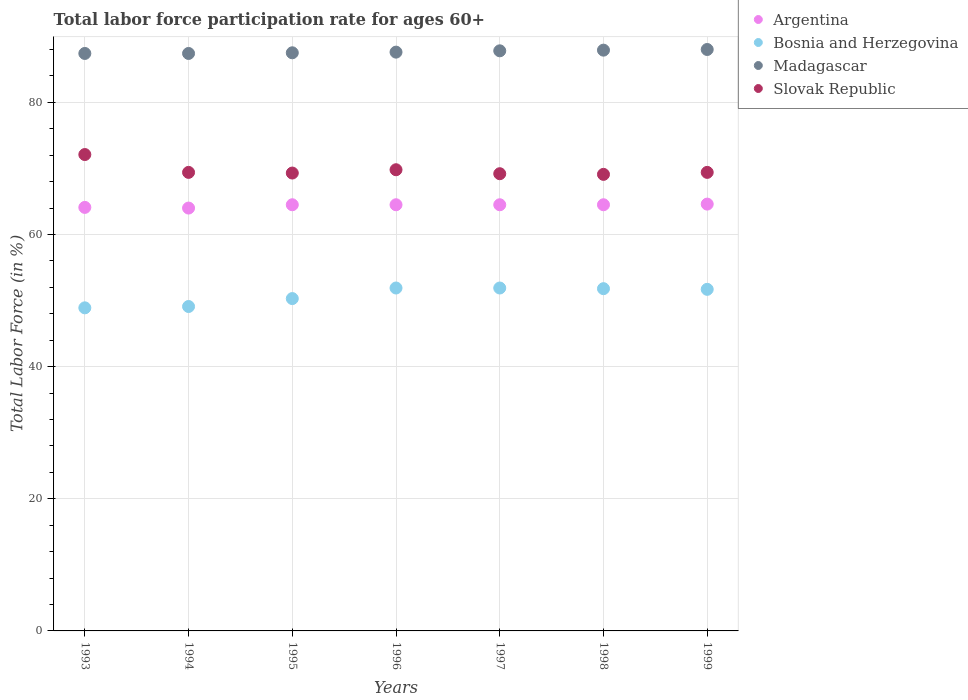How many different coloured dotlines are there?
Provide a short and direct response. 4. What is the labor force participation rate in Bosnia and Herzegovina in 1996?
Your answer should be very brief. 51.9. Across all years, what is the minimum labor force participation rate in Bosnia and Herzegovina?
Your response must be concise. 48.9. In which year was the labor force participation rate in Madagascar maximum?
Give a very brief answer. 1999. What is the total labor force participation rate in Argentina in the graph?
Your answer should be compact. 450.7. What is the difference between the labor force participation rate in Bosnia and Herzegovina in 1995 and that in 1997?
Your answer should be compact. -1.6. What is the difference between the labor force participation rate in Madagascar in 1995 and the labor force participation rate in Slovak Republic in 1999?
Offer a terse response. 18.1. What is the average labor force participation rate in Bosnia and Herzegovina per year?
Offer a very short reply. 50.8. In the year 1998, what is the difference between the labor force participation rate in Madagascar and labor force participation rate in Argentina?
Give a very brief answer. 23.4. What is the ratio of the labor force participation rate in Argentina in 1994 to that in 1997?
Your answer should be compact. 0.99. What is the difference between the highest and the second highest labor force participation rate in Madagascar?
Give a very brief answer. 0.1. What is the difference between the highest and the lowest labor force participation rate in Madagascar?
Give a very brief answer. 0.6. Is it the case that in every year, the sum of the labor force participation rate in Slovak Republic and labor force participation rate in Argentina  is greater than the sum of labor force participation rate in Bosnia and Herzegovina and labor force participation rate in Madagascar?
Keep it short and to the point. Yes. Is it the case that in every year, the sum of the labor force participation rate in Slovak Republic and labor force participation rate in Argentina  is greater than the labor force participation rate in Bosnia and Herzegovina?
Your answer should be compact. Yes. Is the labor force participation rate in Argentina strictly greater than the labor force participation rate in Bosnia and Herzegovina over the years?
Offer a very short reply. Yes. Is the labor force participation rate in Slovak Republic strictly less than the labor force participation rate in Bosnia and Herzegovina over the years?
Give a very brief answer. No. How many years are there in the graph?
Make the answer very short. 7. Are the values on the major ticks of Y-axis written in scientific E-notation?
Ensure brevity in your answer.  No. Does the graph contain grids?
Offer a terse response. Yes. What is the title of the graph?
Keep it short and to the point. Total labor force participation rate for ages 60+. Does "Algeria" appear as one of the legend labels in the graph?
Ensure brevity in your answer.  No. What is the Total Labor Force (in %) of Argentina in 1993?
Make the answer very short. 64.1. What is the Total Labor Force (in %) in Bosnia and Herzegovina in 1993?
Provide a succinct answer. 48.9. What is the Total Labor Force (in %) in Madagascar in 1993?
Your answer should be very brief. 87.4. What is the Total Labor Force (in %) of Slovak Republic in 1993?
Keep it short and to the point. 72.1. What is the Total Labor Force (in %) in Bosnia and Herzegovina in 1994?
Your response must be concise. 49.1. What is the Total Labor Force (in %) of Madagascar in 1994?
Your answer should be compact. 87.4. What is the Total Labor Force (in %) of Slovak Republic in 1994?
Offer a terse response. 69.4. What is the Total Labor Force (in %) of Argentina in 1995?
Provide a short and direct response. 64.5. What is the Total Labor Force (in %) of Bosnia and Herzegovina in 1995?
Provide a short and direct response. 50.3. What is the Total Labor Force (in %) of Madagascar in 1995?
Provide a succinct answer. 87.5. What is the Total Labor Force (in %) in Slovak Republic in 1995?
Keep it short and to the point. 69.3. What is the Total Labor Force (in %) in Argentina in 1996?
Provide a short and direct response. 64.5. What is the Total Labor Force (in %) of Bosnia and Herzegovina in 1996?
Ensure brevity in your answer.  51.9. What is the Total Labor Force (in %) in Madagascar in 1996?
Ensure brevity in your answer.  87.6. What is the Total Labor Force (in %) in Slovak Republic in 1996?
Keep it short and to the point. 69.8. What is the Total Labor Force (in %) in Argentina in 1997?
Make the answer very short. 64.5. What is the Total Labor Force (in %) of Bosnia and Herzegovina in 1997?
Keep it short and to the point. 51.9. What is the Total Labor Force (in %) in Madagascar in 1997?
Make the answer very short. 87.8. What is the Total Labor Force (in %) in Slovak Republic in 1997?
Offer a terse response. 69.2. What is the Total Labor Force (in %) in Argentina in 1998?
Your answer should be very brief. 64.5. What is the Total Labor Force (in %) of Bosnia and Herzegovina in 1998?
Offer a very short reply. 51.8. What is the Total Labor Force (in %) in Madagascar in 1998?
Offer a terse response. 87.9. What is the Total Labor Force (in %) in Slovak Republic in 1998?
Provide a succinct answer. 69.1. What is the Total Labor Force (in %) of Argentina in 1999?
Give a very brief answer. 64.6. What is the Total Labor Force (in %) in Bosnia and Herzegovina in 1999?
Your answer should be very brief. 51.7. What is the Total Labor Force (in %) in Slovak Republic in 1999?
Make the answer very short. 69.4. Across all years, what is the maximum Total Labor Force (in %) in Argentina?
Offer a very short reply. 64.6. Across all years, what is the maximum Total Labor Force (in %) in Bosnia and Herzegovina?
Offer a very short reply. 51.9. Across all years, what is the maximum Total Labor Force (in %) in Slovak Republic?
Offer a terse response. 72.1. Across all years, what is the minimum Total Labor Force (in %) of Bosnia and Herzegovina?
Offer a very short reply. 48.9. Across all years, what is the minimum Total Labor Force (in %) of Madagascar?
Provide a short and direct response. 87.4. Across all years, what is the minimum Total Labor Force (in %) of Slovak Republic?
Your answer should be very brief. 69.1. What is the total Total Labor Force (in %) in Argentina in the graph?
Offer a very short reply. 450.7. What is the total Total Labor Force (in %) of Bosnia and Herzegovina in the graph?
Provide a short and direct response. 355.6. What is the total Total Labor Force (in %) of Madagascar in the graph?
Your response must be concise. 613.6. What is the total Total Labor Force (in %) of Slovak Republic in the graph?
Give a very brief answer. 488.3. What is the difference between the Total Labor Force (in %) of Argentina in 1993 and that in 1994?
Your answer should be very brief. 0.1. What is the difference between the Total Labor Force (in %) of Bosnia and Herzegovina in 1993 and that in 1994?
Provide a succinct answer. -0.2. What is the difference between the Total Labor Force (in %) in Madagascar in 1993 and that in 1994?
Your answer should be very brief. 0. What is the difference between the Total Labor Force (in %) of Slovak Republic in 1993 and that in 1994?
Offer a very short reply. 2.7. What is the difference between the Total Labor Force (in %) in Argentina in 1993 and that in 1995?
Your answer should be compact. -0.4. What is the difference between the Total Labor Force (in %) in Bosnia and Herzegovina in 1993 and that in 1995?
Ensure brevity in your answer.  -1.4. What is the difference between the Total Labor Force (in %) in Madagascar in 1993 and that in 1995?
Provide a short and direct response. -0.1. What is the difference between the Total Labor Force (in %) of Argentina in 1993 and that in 1996?
Provide a succinct answer. -0.4. What is the difference between the Total Labor Force (in %) in Argentina in 1993 and that in 1997?
Offer a terse response. -0.4. What is the difference between the Total Labor Force (in %) in Madagascar in 1993 and that in 1997?
Your response must be concise. -0.4. What is the difference between the Total Labor Force (in %) in Bosnia and Herzegovina in 1993 and that in 1998?
Your answer should be compact. -2.9. What is the difference between the Total Labor Force (in %) in Argentina in 1993 and that in 1999?
Offer a very short reply. -0.5. What is the difference between the Total Labor Force (in %) of Bosnia and Herzegovina in 1993 and that in 1999?
Provide a short and direct response. -2.8. What is the difference between the Total Labor Force (in %) in Madagascar in 1993 and that in 1999?
Your response must be concise. -0.6. What is the difference between the Total Labor Force (in %) in Argentina in 1994 and that in 1995?
Offer a very short reply. -0.5. What is the difference between the Total Labor Force (in %) in Madagascar in 1994 and that in 1995?
Provide a succinct answer. -0.1. What is the difference between the Total Labor Force (in %) of Argentina in 1994 and that in 1996?
Make the answer very short. -0.5. What is the difference between the Total Labor Force (in %) in Madagascar in 1994 and that in 1996?
Provide a succinct answer. -0.2. What is the difference between the Total Labor Force (in %) in Argentina in 1994 and that in 1997?
Your response must be concise. -0.5. What is the difference between the Total Labor Force (in %) in Slovak Republic in 1994 and that in 1997?
Keep it short and to the point. 0.2. What is the difference between the Total Labor Force (in %) in Argentina in 1994 and that in 1998?
Your answer should be very brief. -0.5. What is the difference between the Total Labor Force (in %) of Bosnia and Herzegovina in 1994 and that in 1998?
Keep it short and to the point. -2.7. What is the difference between the Total Labor Force (in %) in Slovak Republic in 1994 and that in 1999?
Your answer should be very brief. 0. What is the difference between the Total Labor Force (in %) in Argentina in 1995 and that in 1996?
Provide a succinct answer. 0. What is the difference between the Total Labor Force (in %) in Bosnia and Herzegovina in 1995 and that in 1996?
Offer a very short reply. -1.6. What is the difference between the Total Labor Force (in %) in Bosnia and Herzegovina in 1995 and that in 1997?
Your response must be concise. -1.6. What is the difference between the Total Labor Force (in %) in Slovak Republic in 1995 and that in 1997?
Give a very brief answer. 0.1. What is the difference between the Total Labor Force (in %) of Madagascar in 1995 and that in 1998?
Offer a very short reply. -0.4. What is the difference between the Total Labor Force (in %) of Slovak Republic in 1995 and that in 1998?
Your answer should be very brief. 0.2. What is the difference between the Total Labor Force (in %) of Argentina in 1995 and that in 1999?
Provide a succinct answer. -0.1. What is the difference between the Total Labor Force (in %) of Slovak Republic in 1995 and that in 1999?
Give a very brief answer. -0.1. What is the difference between the Total Labor Force (in %) in Argentina in 1996 and that in 1997?
Provide a short and direct response. 0. What is the difference between the Total Labor Force (in %) of Bosnia and Herzegovina in 1996 and that in 1997?
Offer a terse response. 0. What is the difference between the Total Labor Force (in %) of Madagascar in 1996 and that in 1997?
Ensure brevity in your answer.  -0.2. What is the difference between the Total Labor Force (in %) in Argentina in 1996 and that in 1998?
Give a very brief answer. 0. What is the difference between the Total Labor Force (in %) in Madagascar in 1996 and that in 1998?
Provide a short and direct response. -0.3. What is the difference between the Total Labor Force (in %) of Madagascar in 1996 and that in 1999?
Make the answer very short. -0.4. What is the difference between the Total Labor Force (in %) of Slovak Republic in 1996 and that in 1999?
Keep it short and to the point. 0.4. What is the difference between the Total Labor Force (in %) of Bosnia and Herzegovina in 1997 and that in 1998?
Your answer should be very brief. 0.1. What is the difference between the Total Labor Force (in %) of Argentina in 1997 and that in 1999?
Provide a short and direct response. -0.1. What is the difference between the Total Labor Force (in %) in Madagascar in 1997 and that in 1999?
Ensure brevity in your answer.  -0.2. What is the difference between the Total Labor Force (in %) in Argentina in 1998 and that in 1999?
Your answer should be compact. -0.1. What is the difference between the Total Labor Force (in %) in Bosnia and Herzegovina in 1998 and that in 1999?
Ensure brevity in your answer.  0.1. What is the difference between the Total Labor Force (in %) in Madagascar in 1998 and that in 1999?
Provide a short and direct response. -0.1. What is the difference between the Total Labor Force (in %) of Slovak Republic in 1998 and that in 1999?
Provide a succinct answer. -0.3. What is the difference between the Total Labor Force (in %) in Argentina in 1993 and the Total Labor Force (in %) in Madagascar in 1994?
Keep it short and to the point. -23.3. What is the difference between the Total Labor Force (in %) of Bosnia and Herzegovina in 1993 and the Total Labor Force (in %) of Madagascar in 1994?
Provide a succinct answer. -38.5. What is the difference between the Total Labor Force (in %) of Bosnia and Herzegovina in 1993 and the Total Labor Force (in %) of Slovak Republic in 1994?
Give a very brief answer. -20.5. What is the difference between the Total Labor Force (in %) of Argentina in 1993 and the Total Labor Force (in %) of Bosnia and Herzegovina in 1995?
Your answer should be very brief. 13.8. What is the difference between the Total Labor Force (in %) in Argentina in 1993 and the Total Labor Force (in %) in Madagascar in 1995?
Provide a succinct answer. -23.4. What is the difference between the Total Labor Force (in %) of Bosnia and Herzegovina in 1993 and the Total Labor Force (in %) of Madagascar in 1995?
Provide a short and direct response. -38.6. What is the difference between the Total Labor Force (in %) of Bosnia and Herzegovina in 1993 and the Total Labor Force (in %) of Slovak Republic in 1995?
Ensure brevity in your answer.  -20.4. What is the difference between the Total Labor Force (in %) of Argentina in 1993 and the Total Labor Force (in %) of Madagascar in 1996?
Offer a very short reply. -23.5. What is the difference between the Total Labor Force (in %) in Argentina in 1993 and the Total Labor Force (in %) in Slovak Republic in 1996?
Give a very brief answer. -5.7. What is the difference between the Total Labor Force (in %) in Bosnia and Herzegovina in 1993 and the Total Labor Force (in %) in Madagascar in 1996?
Provide a short and direct response. -38.7. What is the difference between the Total Labor Force (in %) in Bosnia and Herzegovina in 1993 and the Total Labor Force (in %) in Slovak Republic in 1996?
Keep it short and to the point. -20.9. What is the difference between the Total Labor Force (in %) in Madagascar in 1993 and the Total Labor Force (in %) in Slovak Republic in 1996?
Make the answer very short. 17.6. What is the difference between the Total Labor Force (in %) in Argentina in 1993 and the Total Labor Force (in %) in Bosnia and Herzegovina in 1997?
Your answer should be very brief. 12.2. What is the difference between the Total Labor Force (in %) of Argentina in 1993 and the Total Labor Force (in %) of Madagascar in 1997?
Your answer should be very brief. -23.7. What is the difference between the Total Labor Force (in %) of Argentina in 1993 and the Total Labor Force (in %) of Slovak Republic in 1997?
Your answer should be compact. -5.1. What is the difference between the Total Labor Force (in %) in Bosnia and Herzegovina in 1993 and the Total Labor Force (in %) in Madagascar in 1997?
Your answer should be very brief. -38.9. What is the difference between the Total Labor Force (in %) of Bosnia and Herzegovina in 1993 and the Total Labor Force (in %) of Slovak Republic in 1997?
Offer a very short reply. -20.3. What is the difference between the Total Labor Force (in %) in Madagascar in 1993 and the Total Labor Force (in %) in Slovak Republic in 1997?
Ensure brevity in your answer.  18.2. What is the difference between the Total Labor Force (in %) in Argentina in 1993 and the Total Labor Force (in %) in Madagascar in 1998?
Your answer should be compact. -23.8. What is the difference between the Total Labor Force (in %) of Argentina in 1993 and the Total Labor Force (in %) of Slovak Republic in 1998?
Your response must be concise. -5. What is the difference between the Total Labor Force (in %) of Bosnia and Herzegovina in 1993 and the Total Labor Force (in %) of Madagascar in 1998?
Give a very brief answer. -39. What is the difference between the Total Labor Force (in %) in Bosnia and Herzegovina in 1993 and the Total Labor Force (in %) in Slovak Republic in 1998?
Keep it short and to the point. -20.2. What is the difference between the Total Labor Force (in %) of Madagascar in 1993 and the Total Labor Force (in %) of Slovak Republic in 1998?
Make the answer very short. 18.3. What is the difference between the Total Labor Force (in %) in Argentina in 1993 and the Total Labor Force (in %) in Madagascar in 1999?
Ensure brevity in your answer.  -23.9. What is the difference between the Total Labor Force (in %) of Bosnia and Herzegovina in 1993 and the Total Labor Force (in %) of Madagascar in 1999?
Give a very brief answer. -39.1. What is the difference between the Total Labor Force (in %) in Bosnia and Herzegovina in 1993 and the Total Labor Force (in %) in Slovak Republic in 1999?
Give a very brief answer. -20.5. What is the difference between the Total Labor Force (in %) of Argentina in 1994 and the Total Labor Force (in %) of Madagascar in 1995?
Provide a short and direct response. -23.5. What is the difference between the Total Labor Force (in %) in Bosnia and Herzegovina in 1994 and the Total Labor Force (in %) in Madagascar in 1995?
Provide a short and direct response. -38.4. What is the difference between the Total Labor Force (in %) of Bosnia and Herzegovina in 1994 and the Total Labor Force (in %) of Slovak Republic in 1995?
Your answer should be very brief. -20.2. What is the difference between the Total Labor Force (in %) in Madagascar in 1994 and the Total Labor Force (in %) in Slovak Republic in 1995?
Keep it short and to the point. 18.1. What is the difference between the Total Labor Force (in %) of Argentina in 1994 and the Total Labor Force (in %) of Madagascar in 1996?
Offer a terse response. -23.6. What is the difference between the Total Labor Force (in %) of Bosnia and Herzegovina in 1994 and the Total Labor Force (in %) of Madagascar in 1996?
Provide a succinct answer. -38.5. What is the difference between the Total Labor Force (in %) of Bosnia and Herzegovina in 1994 and the Total Labor Force (in %) of Slovak Republic in 1996?
Provide a short and direct response. -20.7. What is the difference between the Total Labor Force (in %) of Argentina in 1994 and the Total Labor Force (in %) of Madagascar in 1997?
Give a very brief answer. -23.8. What is the difference between the Total Labor Force (in %) of Bosnia and Herzegovina in 1994 and the Total Labor Force (in %) of Madagascar in 1997?
Give a very brief answer. -38.7. What is the difference between the Total Labor Force (in %) of Bosnia and Herzegovina in 1994 and the Total Labor Force (in %) of Slovak Republic in 1997?
Your response must be concise. -20.1. What is the difference between the Total Labor Force (in %) of Argentina in 1994 and the Total Labor Force (in %) of Bosnia and Herzegovina in 1998?
Your answer should be compact. 12.2. What is the difference between the Total Labor Force (in %) of Argentina in 1994 and the Total Labor Force (in %) of Madagascar in 1998?
Your answer should be compact. -23.9. What is the difference between the Total Labor Force (in %) of Bosnia and Herzegovina in 1994 and the Total Labor Force (in %) of Madagascar in 1998?
Your answer should be compact. -38.8. What is the difference between the Total Labor Force (in %) of Madagascar in 1994 and the Total Labor Force (in %) of Slovak Republic in 1998?
Keep it short and to the point. 18.3. What is the difference between the Total Labor Force (in %) of Argentina in 1994 and the Total Labor Force (in %) of Bosnia and Herzegovina in 1999?
Keep it short and to the point. 12.3. What is the difference between the Total Labor Force (in %) in Bosnia and Herzegovina in 1994 and the Total Labor Force (in %) in Madagascar in 1999?
Provide a succinct answer. -38.9. What is the difference between the Total Labor Force (in %) in Bosnia and Herzegovina in 1994 and the Total Labor Force (in %) in Slovak Republic in 1999?
Provide a succinct answer. -20.3. What is the difference between the Total Labor Force (in %) in Madagascar in 1994 and the Total Labor Force (in %) in Slovak Republic in 1999?
Offer a very short reply. 18. What is the difference between the Total Labor Force (in %) in Argentina in 1995 and the Total Labor Force (in %) in Bosnia and Herzegovina in 1996?
Your answer should be very brief. 12.6. What is the difference between the Total Labor Force (in %) in Argentina in 1995 and the Total Labor Force (in %) in Madagascar in 1996?
Your response must be concise. -23.1. What is the difference between the Total Labor Force (in %) of Bosnia and Herzegovina in 1995 and the Total Labor Force (in %) of Madagascar in 1996?
Ensure brevity in your answer.  -37.3. What is the difference between the Total Labor Force (in %) of Bosnia and Herzegovina in 1995 and the Total Labor Force (in %) of Slovak Republic in 1996?
Give a very brief answer. -19.5. What is the difference between the Total Labor Force (in %) of Madagascar in 1995 and the Total Labor Force (in %) of Slovak Republic in 1996?
Your response must be concise. 17.7. What is the difference between the Total Labor Force (in %) of Argentina in 1995 and the Total Labor Force (in %) of Madagascar in 1997?
Make the answer very short. -23.3. What is the difference between the Total Labor Force (in %) of Argentina in 1995 and the Total Labor Force (in %) of Slovak Republic in 1997?
Provide a short and direct response. -4.7. What is the difference between the Total Labor Force (in %) of Bosnia and Herzegovina in 1995 and the Total Labor Force (in %) of Madagascar in 1997?
Your answer should be compact. -37.5. What is the difference between the Total Labor Force (in %) in Bosnia and Herzegovina in 1995 and the Total Labor Force (in %) in Slovak Republic in 1997?
Provide a short and direct response. -18.9. What is the difference between the Total Labor Force (in %) of Madagascar in 1995 and the Total Labor Force (in %) of Slovak Republic in 1997?
Offer a very short reply. 18.3. What is the difference between the Total Labor Force (in %) in Argentina in 1995 and the Total Labor Force (in %) in Madagascar in 1998?
Your answer should be very brief. -23.4. What is the difference between the Total Labor Force (in %) in Argentina in 1995 and the Total Labor Force (in %) in Slovak Republic in 1998?
Your answer should be very brief. -4.6. What is the difference between the Total Labor Force (in %) in Bosnia and Herzegovina in 1995 and the Total Labor Force (in %) in Madagascar in 1998?
Your answer should be very brief. -37.6. What is the difference between the Total Labor Force (in %) in Bosnia and Herzegovina in 1995 and the Total Labor Force (in %) in Slovak Republic in 1998?
Your response must be concise. -18.8. What is the difference between the Total Labor Force (in %) in Madagascar in 1995 and the Total Labor Force (in %) in Slovak Republic in 1998?
Provide a short and direct response. 18.4. What is the difference between the Total Labor Force (in %) in Argentina in 1995 and the Total Labor Force (in %) in Madagascar in 1999?
Make the answer very short. -23.5. What is the difference between the Total Labor Force (in %) in Argentina in 1995 and the Total Labor Force (in %) in Slovak Republic in 1999?
Provide a short and direct response. -4.9. What is the difference between the Total Labor Force (in %) in Bosnia and Herzegovina in 1995 and the Total Labor Force (in %) in Madagascar in 1999?
Give a very brief answer. -37.7. What is the difference between the Total Labor Force (in %) in Bosnia and Herzegovina in 1995 and the Total Labor Force (in %) in Slovak Republic in 1999?
Ensure brevity in your answer.  -19.1. What is the difference between the Total Labor Force (in %) in Madagascar in 1995 and the Total Labor Force (in %) in Slovak Republic in 1999?
Ensure brevity in your answer.  18.1. What is the difference between the Total Labor Force (in %) in Argentina in 1996 and the Total Labor Force (in %) in Madagascar in 1997?
Offer a very short reply. -23.3. What is the difference between the Total Labor Force (in %) of Argentina in 1996 and the Total Labor Force (in %) of Slovak Republic in 1997?
Ensure brevity in your answer.  -4.7. What is the difference between the Total Labor Force (in %) in Bosnia and Herzegovina in 1996 and the Total Labor Force (in %) in Madagascar in 1997?
Offer a terse response. -35.9. What is the difference between the Total Labor Force (in %) in Bosnia and Herzegovina in 1996 and the Total Labor Force (in %) in Slovak Republic in 1997?
Your answer should be compact. -17.3. What is the difference between the Total Labor Force (in %) of Argentina in 1996 and the Total Labor Force (in %) of Bosnia and Herzegovina in 1998?
Give a very brief answer. 12.7. What is the difference between the Total Labor Force (in %) in Argentina in 1996 and the Total Labor Force (in %) in Madagascar in 1998?
Offer a terse response. -23.4. What is the difference between the Total Labor Force (in %) of Bosnia and Herzegovina in 1996 and the Total Labor Force (in %) of Madagascar in 1998?
Your answer should be very brief. -36. What is the difference between the Total Labor Force (in %) of Bosnia and Herzegovina in 1996 and the Total Labor Force (in %) of Slovak Republic in 1998?
Your answer should be compact. -17.2. What is the difference between the Total Labor Force (in %) in Madagascar in 1996 and the Total Labor Force (in %) in Slovak Republic in 1998?
Provide a succinct answer. 18.5. What is the difference between the Total Labor Force (in %) of Argentina in 1996 and the Total Labor Force (in %) of Madagascar in 1999?
Offer a terse response. -23.5. What is the difference between the Total Labor Force (in %) in Argentina in 1996 and the Total Labor Force (in %) in Slovak Republic in 1999?
Offer a terse response. -4.9. What is the difference between the Total Labor Force (in %) of Bosnia and Herzegovina in 1996 and the Total Labor Force (in %) of Madagascar in 1999?
Provide a succinct answer. -36.1. What is the difference between the Total Labor Force (in %) in Bosnia and Herzegovina in 1996 and the Total Labor Force (in %) in Slovak Republic in 1999?
Offer a terse response. -17.5. What is the difference between the Total Labor Force (in %) in Madagascar in 1996 and the Total Labor Force (in %) in Slovak Republic in 1999?
Provide a succinct answer. 18.2. What is the difference between the Total Labor Force (in %) in Argentina in 1997 and the Total Labor Force (in %) in Bosnia and Herzegovina in 1998?
Offer a very short reply. 12.7. What is the difference between the Total Labor Force (in %) of Argentina in 1997 and the Total Labor Force (in %) of Madagascar in 1998?
Offer a very short reply. -23.4. What is the difference between the Total Labor Force (in %) in Bosnia and Herzegovina in 1997 and the Total Labor Force (in %) in Madagascar in 1998?
Give a very brief answer. -36. What is the difference between the Total Labor Force (in %) of Bosnia and Herzegovina in 1997 and the Total Labor Force (in %) of Slovak Republic in 1998?
Provide a succinct answer. -17.2. What is the difference between the Total Labor Force (in %) of Argentina in 1997 and the Total Labor Force (in %) of Madagascar in 1999?
Make the answer very short. -23.5. What is the difference between the Total Labor Force (in %) of Argentina in 1997 and the Total Labor Force (in %) of Slovak Republic in 1999?
Provide a succinct answer. -4.9. What is the difference between the Total Labor Force (in %) of Bosnia and Herzegovina in 1997 and the Total Labor Force (in %) of Madagascar in 1999?
Offer a terse response. -36.1. What is the difference between the Total Labor Force (in %) of Bosnia and Herzegovina in 1997 and the Total Labor Force (in %) of Slovak Republic in 1999?
Your answer should be compact. -17.5. What is the difference between the Total Labor Force (in %) in Argentina in 1998 and the Total Labor Force (in %) in Bosnia and Herzegovina in 1999?
Make the answer very short. 12.8. What is the difference between the Total Labor Force (in %) of Argentina in 1998 and the Total Labor Force (in %) of Madagascar in 1999?
Ensure brevity in your answer.  -23.5. What is the difference between the Total Labor Force (in %) in Argentina in 1998 and the Total Labor Force (in %) in Slovak Republic in 1999?
Your answer should be compact. -4.9. What is the difference between the Total Labor Force (in %) of Bosnia and Herzegovina in 1998 and the Total Labor Force (in %) of Madagascar in 1999?
Your response must be concise. -36.2. What is the difference between the Total Labor Force (in %) of Bosnia and Herzegovina in 1998 and the Total Labor Force (in %) of Slovak Republic in 1999?
Provide a succinct answer. -17.6. What is the difference between the Total Labor Force (in %) of Madagascar in 1998 and the Total Labor Force (in %) of Slovak Republic in 1999?
Provide a short and direct response. 18.5. What is the average Total Labor Force (in %) in Argentina per year?
Your answer should be compact. 64.39. What is the average Total Labor Force (in %) in Bosnia and Herzegovina per year?
Offer a very short reply. 50.8. What is the average Total Labor Force (in %) in Madagascar per year?
Provide a succinct answer. 87.66. What is the average Total Labor Force (in %) in Slovak Republic per year?
Offer a terse response. 69.76. In the year 1993, what is the difference between the Total Labor Force (in %) in Argentina and Total Labor Force (in %) in Bosnia and Herzegovina?
Offer a very short reply. 15.2. In the year 1993, what is the difference between the Total Labor Force (in %) of Argentina and Total Labor Force (in %) of Madagascar?
Give a very brief answer. -23.3. In the year 1993, what is the difference between the Total Labor Force (in %) in Argentina and Total Labor Force (in %) in Slovak Republic?
Give a very brief answer. -8. In the year 1993, what is the difference between the Total Labor Force (in %) in Bosnia and Herzegovina and Total Labor Force (in %) in Madagascar?
Give a very brief answer. -38.5. In the year 1993, what is the difference between the Total Labor Force (in %) in Bosnia and Herzegovina and Total Labor Force (in %) in Slovak Republic?
Make the answer very short. -23.2. In the year 1994, what is the difference between the Total Labor Force (in %) of Argentina and Total Labor Force (in %) of Bosnia and Herzegovina?
Make the answer very short. 14.9. In the year 1994, what is the difference between the Total Labor Force (in %) of Argentina and Total Labor Force (in %) of Madagascar?
Your answer should be very brief. -23.4. In the year 1994, what is the difference between the Total Labor Force (in %) of Argentina and Total Labor Force (in %) of Slovak Republic?
Provide a succinct answer. -5.4. In the year 1994, what is the difference between the Total Labor Force (in %) in Bosnia and Herzegovina and Total Labor Force (in %) in Madagascar?
Provide a succinct answer. -38.3. In the year 1994, what is the difference between the Total Labor Force (in %) of Bosnia and Herzegovina and Total Labor Force (in %) of Slovak Republic?
Your response must be concise. -20.3. In the year 1995, what is the difference between the Total Labor Force (in %) of Argentina and Total Labor Force (in %) of Madagascar?
Provide a succinct answer. -23. In the year 1995, what is the difference between the Total Labor Force (in %) in Bosnia and Herzegovina and Total Labor Force (in %) in Madagascar?
Ensure brevity in your answer.  -37.2. In the year 1995, what is the difference between the Total Labor Force (in %) of Madagascar and Total Labor Force (in %) of Slovak Republic?
Offer a very short reply. 18.2. In the year 1996, what is the difference between the Total Labor Force (in %) of Argentina and Total Labor Force (in %) of Bosnia and Herzegovina?
Your answer should be very brief. 12.6. In the year 1996, what is the difference between the Total Labor Force (in %) of Argentina and Total Labor Force (in %) of Madagascar?
Your answer should be very brief. -23.1. In the year 1996, what is the difference between the Total Labor Force (in %) of Argentina and Total Labor Force (in %) of Slovak Republic?
Ensure brevity in your answer.  -5.3. In the year 1996, what is the difference between the Total Labor Force (in %) in Bosnia and Herzegovina and Total Labor Force (in %) in Madagascar?
Your answer should be very brief. -35.7. In the year 1996, what is the difference between the Total Labor Force (in %) in Bosnia and Herzegovina and Total Labor Force (in %) in Slovak Republic?
Keep it short and to the point. -17.9. In the year 1996, what is the difference between the Total Labor Force (in %) in Madagascar and Total Labor Force (in %) in Slovak Republic?
Offer a terse response. 17.8. In the year 1997, what is the difference between the Total Labor Force (in %) of Argentina and Total Labor Force (in %) of Bosnia and Herzegovina?
Your answer should be compact. 12.6. In the year 1997, what is the difference between the Total Labor Force (in %) of Argentina and Total Labor Force (in %) of Madagascar?
Offer a very short reply. -23.3. In the year 1997, what is the difference between the Total Labor Force (in %) of Argentina and Total Labor Force (in %) of Slovak Republic?
Give a very brief answer. -4.7. In the year 1997, what is the difference between the Total Labor Force (in %) of Bosnia and Herzegovina and Total Labor Force (in %) of Madagascar?
Provide a short and direct response. -35.9. In the year 1997, what is the difference between the Total Labor Force (in %) in Bosnia and Herzegovina and Total Labor Force (in %) in Slovak Republic?
Provide a succinct answer. -17.3. In the year 1998, what is the difference between the Total Labor Force (in %) of Argentina and Total Labor Force (in %) of Madagascar?
Offer a terse response. -23.4. In the year 1998, what is the difference between the Total Labor Force (in %) of Argentina and Total Labor Force (in %) of Slovak Republic?
Keep it short and to the point. -4.6. In the year 1998, what is the difference between the Total Labor Force (in %) in Bosnia and Herzegovina and Total Labor Force (in %) in Madagascar?
Keep it short and to the point. -36.1. In the year 1998, what is the difference between the Total Labor Force (in %) in Bosnia and Herzegovina and Total Labor Force (in %) in Slovak Republic?
Offer a very short reply. -17.3. In the year 1998, what is the difference between the Total Labor Force (in %) of Madagascar and Total Labor Force (in %) of Slovak Republic?
Ensure brevity in your answer.  18.8. In the year 1999, what is the difference between the Total Labor Force (in %) of Argentina and Total Labor Force (in %) of Bosnia and Herzegovina?
Make the answer very short. 12.9. In the year 1999, what is the difference between the Total Labor Force (in %) in Argentina and Total Labor Force (in %) in Madagascar?
Your answer should be compact. -23.4. In the year 1999, what is the difference between the Total Labor Force (in %) in Bosnia and Herzegovina and Total Labor Force (in %) in Madagascar?
Your response must be concise. -36.3. In the year 1999, what is the difference between the Total Labor Force (in %) in Bosnia and Herzegovina and Total Labor Force (in %) in Slovak Republic?
Provide a short and direct response. -17.7. What is the ratio of the Total Labor Force (in %) of Bosnia and Herzegovina in 1993 to that in 1994?
Give a very brief answer. 1. What is the ratio of the Total Labor Force (in %) in Slovak Republic in 1993 to that in 1994?
Ensure brevity in your answer.  1.04. What is the ratio of the Total Labor Force (in %) of Argentina in 1993 to that in 1995?
Ensure brevity in your answer.  0.99. What is the ratio of the Total Labor Force (in %) of Bosnia and Herzegovina in 1993 to that in 1995?
Your response must be concise. 0.97. What is the ratio of the Total Labor Force (in %) of Madagascar in 1993 to that in 1995?
Your answer should be very brief. 1. What is the ratio of the Total Labor Force (in %) of Slovak Republic in 1993 to that in 1995?
Give a very brief answer. 1.04. What is the ratio of the Total Labor Force (in %) of Argentina in 1993 to that in 1996?
Offer a very short reply. 0.99. What is the ratio of the Total Labor Force (in %) of Bosnia and Herzegovina in 1993 to that in 1996?
Your answer should be compact. 0.94. What is the ratio of the Total Labor Force (in %) in Slovak Republic in 1993 to that in 1996?
Give a very brief answer. 1.03. What is the ratio of the Total Labor Force (in %) in Argentina in 1993 to that in 1997?
Ensure brevity in your answer.  0.99. What is the ratio of the Total Labor Force (in %) in Bosnia and Herzegovina in 1993 to that in 1997?
Offer a terse response. 0.94. What is the ratio of the Total Labor Force (in %) of Slovak Republic in 1993 to that in 1997?
Your answer should be very brief. 1.04. What is the ratio of the Total Labor Force (in %) in Bosnia and Herzegovina in 1993 to that in 1998?
Offer a very short reply. 0.94. What is the ratio of the Total Labor Force (in %) of Madagascar in 1993 to that in 1998?
Your answer should be compact. 0.99. What is the ratio of the Total Labor Force (in %) of Slovak Republic in 1993 to that in 1998?
Give a very brief answer. 1.04. What is the ratio of the Total Labor Force (in %) in Argentina in 1993 to that in 1999?
Give a very brief answer. 0.99. What is the ratio of the Total Labor Force (in %) of Bosnia and Herzegovina in 1993 to that in 1999?
Your response must be concise. 0.95. What is the ratio of the Total Labor Force (in %) in Madagascar in 1993 to that in 1999?
Make the answer very short. 0.99. What is the ratio of the Total Labor Force (in %) of Slovak Republic in 1993 to that in 1999?
Provide a short and direct response. 1.04. What is the ratio of the Total Labor Force (in %) of Argentina in 1994 to that in 1995?
Your answer should be very brief. 0.99. What is the ratio of the Total Labor Force (in %) in Bosnia and Herzegovina in 1994 to that in 1995?
Offer a very short reply. 0.98. What is the ratio of the Total Labor Force (in %) in Bosnia and Herzegovina in 1994 to that in 1996?
Your answer should be compact. 0.95. What is the ratio of the Total Labor Force (in %) of Madagascar in 1994 to that in 1996?
Give a very brief answer. 1. What is the ratio of the Total Labor Force (in %) in Bosnia and Herzegovina in 1994 to that in 1997?
Offer a terse response. 0.95. What is the ratio of the Total Labor Force (in %) in Madagascar in 1994 to that in 1997?
Offer a very short reply. 1. What is the ratio of the Total Labor Force (in %) of Slovak Republic in 1994 to that in 1997?
Give a very brief answer. 1. What is the ratio of the Total Labor Force (in %) in Bosnia and Herzegovina in 1994 to that in 1998?
Make the answer very short. 0.95. What is the ratio of the Total Labor Force (in %) in Madagascar in 1994 to that in 1998?
Your response must be concise. 0.99. What is the ratio of the Total Labor Force (in %) of Argentina in 1994 to that in 1999?
Make the answer very short. 0.99. What is the ratio of the Total Labor Force (in %) of Bosnia and Herzegovina in 1994 to that in 1999?
Provide a succinct answer. 0.95. What is the ratio of the Total Labor Force (in %) in Argentina in 1995 to that in 1996?
Provide a short and direct response. 1. What is the ratio of the Total Labor Force (in %) in Bosnia and Herzegovina in 1995 to that in 1996?
Ensure brevity in your answer.  0.97. What is the ratio of the Total Labor Force (in %) of Madagascar in 1995 to that in 1996?
Your answer should be compact. 1. What is the ratio of the Total Labor Force (in %) of Argentina in 1995 to that in 1997?
Make the answer very short. 1. What is the ratio of the Total Labor Force (in %) of Bosnia and Herzegovina in 1995 to that in 1997?
Your answer should be very brief. 0.97. What is the ratio of the Total Labor Force (in %) in Madagascar in 1995 to that in 1997?
Provide a short and direct response. 1. What is the ratio of the Total Labor Force (in %) of Slovak Republic in 1995 to that in 1997?
Offer a very short reply. 1. What is the ratio of the Total Labor Force (in %) in Argentina in 1995 to that in 1998?
Keep it short and to the point. 1. What is the ratio of the Total Labor Force (in %) of Bosnia and Herzegovina in 1995 to that in 1998?
Provide a short and direct response. 0.97. What is the ratio of the Total Labor Force (in %) in Argentina in 1995 to that in 1999?
Make the answer very short. 1. What is the ratio of the Total Labor Force (in %) in Bosnia and Herzegovina in 1995 to that in 1999?
Offer a terse response. 0.97. What is the ratio of the Total Labor Force (in %) of Madagascar in 1995 to that in 1999?
Your response must be concise. 0.99. What is the ratio of the Total Labor Force (in %) in Slovak Republic in 1995 to that in 1999?
Provide a succinct answer. 1. What is the ratio of the Total Labor Force (in %) of Argentina in 1996 to that in 1997?
Your response must be concise. 1. What is the ratio of the Total Labor Force (in %) of Bosnia and Herzegovina in 1996 to that in 1997?
Your answer should be very brief. 1. What is the ratio of the Total Labor Force (in %) in Slovak Republic in 1996 to that in 1997?
Ensure brevity in your answer.  1.01. What is the ratio of the Total Labor Force (in %) of Slovak Republic in 1996 to that in 1998?
Offer a terse response. 1.01. What is the ratio of the Total Labor Force (in %) in Argentina in 1996 to that in 1999?
Make the answer very short. 1. What is the ratio of the Total Labor Force (in %) of Madagascar in 1996 to that in 1999?
Keep it short and to the point. 1. What is the ratio of the Total Labor Force (in %) of Slovak Republic in 1996 to that in 1999?
Your answer should be compact. 1.01. What is the ratio of the Total Labor Force (in %) in Madagascar in 1997 to that in 1998?
Your answer should be very brief. 1. What is the ratio of the Total Labor Force (in %) in Slovak Republic in 1997 to that in 1998?
Offer a terse response. 1. What is the ratio of the Total Labor Force (in %) in Madagascar in 1998 to that in 1999?
Offer a very short reply. 1. What is the difference between the highest and the second highest Total Labor Force (in %) in Argentina?
Make the answer very short. 0.1. What is the difference between the highest and the lowest Total Labor Force (in %) of Argentina?
Your response must be concise. 0.6. What is the difference between the highest and the lowest Total Labor Force (in %) of Madagascar?
Offer a very short reply. 0.6. What is the difference between the highest and the lowest Total Labor Force (in %) in Slovak Republic?
Make the answer very short. 3. 